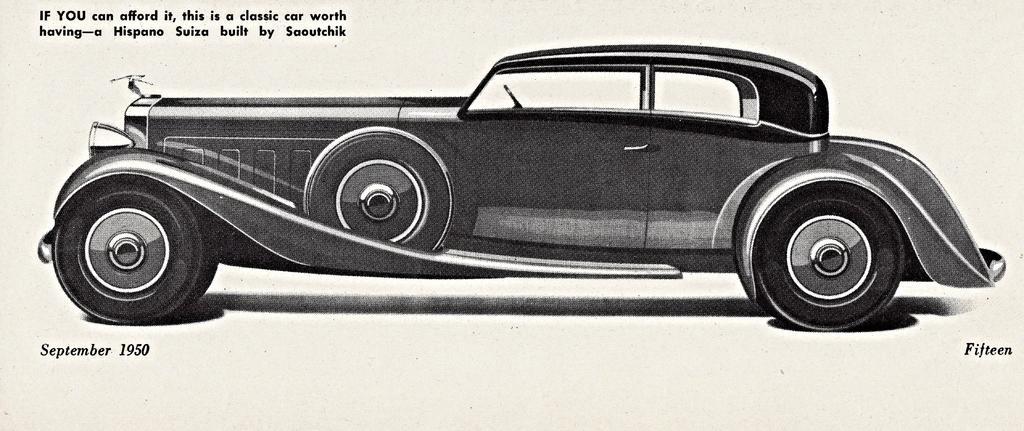How would you summarize this image in a sentence or two? In this image we can see a picture of 1950 model car. 